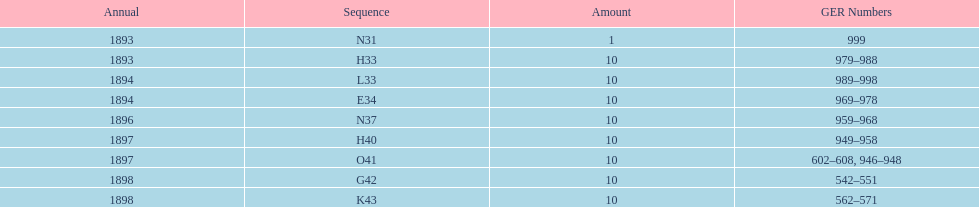What is the order of the last year listed? K43. 